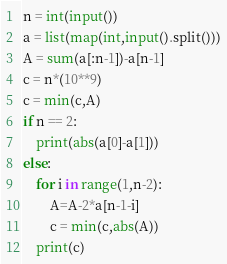<code> <loc_0><loc_0><loc_500><loc_500><_Python_>n = int(input())
a = list(map(int,input().split()))
A = sum(a[:n-1])-a[n-1]
c = n*(10**9)
c = min(c,A)
if n == 2:
    print(abs(a[0]-a[1]))
else:
    for i in range(1,n-2):
        A=A-2*a[n-1-i]
        c = min(c,abs(A))
    print(c)
</code> 